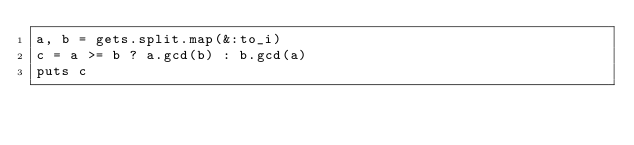Convert code to text. <code><loc_0><loc_0><loc_500><loc_500><_Ruby_>a, b = gets.split.map(&:to_i)
c = a >= b ? a.gcd(b) : b.gcd(a)
puts c</code> 